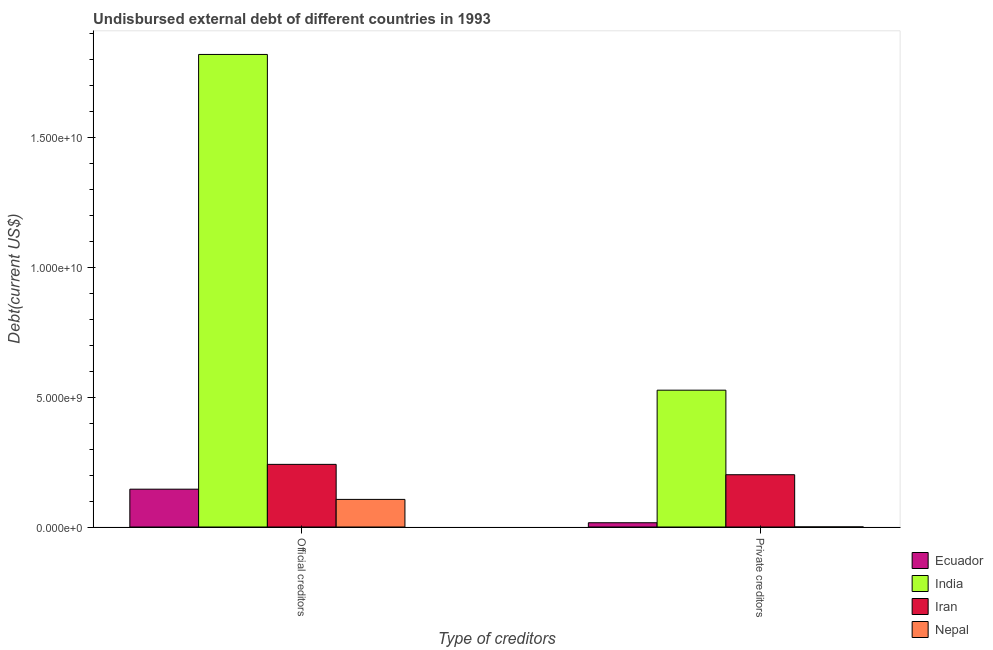How many different coloured bars are there?
Provide a succinct answer. 4. How many groups of bars are there?
Offer a very short reply. 2. Are the number of bars per tick equal to the number of legend labels?
Provide a short and direct response. Yes. Are the number of bars on each tick of the X-axis equal?
Your answer should be very brief. Yes. What is the label of the 1st group of bars from the left?
Make the answer very short. Official creditors. What is the undisbursed external debt of official creditors in Iran?
Provide a succinct answer. 2.41e+09. Across all countries, what is the maximum undisbursed external debt of official creditors?
Give a very brief answer. 1.82e+1. Across all countries, what is the minimum undisbursed external debt of official creditors?
Make the answer very short. 1.06e+09. In which country was the undisbursed external debt of private creditors maximum?
Your answer should be very brief. India. In which country was the undisbursed external debt of private creditors minimum?
Ensure brevity in your answer.  Nepal. What is the total undisbursed external debt of private creditors in the graph?
Your answer should be compact. 7.45e+09. What is the difference between the undisbursed external debt of private creditors in Nepal and that in Iran?
Keep it short and to the point. -2.01e+09. What is the difference between the undisbursed external debt of official creditors in Ecuador and the undisbursed external debt of private creditors in Iran?
Your answer should be compact. -5.56e+08. What is the average undisbursed external debt of official creditors per country?
Your answer should be compact. 5.78e+09. What is the difference between the undisbursed external debt of private creditors and undisbursed external debt of official creditors in India?
Offer a very short reply. -1.29e+1. In how many countries, is the undisbursed external debt of private creditors greater than 16000000000 US$?
Offer a very short reply. 0. What is the ratio of the undisbursed external debt of official creditors in Iran to that in Ecuador?
Provide a short and direct response. 1.66. What does the 4th bar from the left in Official creditors represents?
Offer a terse response. Nepal. What does the 1st bar from the right in Private creditors represents?
Ensure brevity in your answer.  Nepal. How many bars are there?
Give a very brief answer. 8. Are all the bars in the graph horizontal?
Ensure brevity in your answer.  No. Are the values on the major ticks of Y-axis written in scientific E-notation?
Provide a succinct answer. Yes. How many legend labels are there?
Provide a short and direct response. 4. How are the legend labels stacked?
Make the answer very short. Vertical. What is the title of the graph?
Your answer should be very brief. Undisbursed external debt of different countries in 1993. Does "Channel Islands" appear as one of the legend labels in the graph?
Offer a very short reply. No. What is the label or title of the X-axis?
Offer a very short reply. Type of creditors. What is the label or title of the Y-axis?
Your response must be concise. Debt(current US$). What is the Debt(current US$) in Ecuador in Official creditors?
Make the answer very short. 1.46e+09. What is the Debt(current US$) in India in Official creditors?
Ensure brevity in your answer.  1.82e+1. What is the Debt(current US$) in Iran in Official creditors?
Ensure brevity in your answer.  2.41e+09. What is the Debt(current US$) of Nepal in Official creditors?
Provide a succinct answer. 1.06e+09. What is the Debt(current US$) of Ecuador in Private creditors?
Offer a very short reply. 1.64e+08. What is the Debt(current US$) of India in Private creditors?
Give a very brief answer. 5.27e+09. What is the Debt(current US$) in Iran in Private creditors?
Your response must be concise. 2.01e+09. What is the Debt(current US$) of Nepal in Private creditors?
Ensure brevity in your answer.  2.78e+06. Across all Type of creditors, what is the maximum Debt(current US$) in Ecuador?
Provide a short and direct response. 1.46e+09. Across all Type of creditors, what is the maximum Debt(current US$) of India?
Provide a succinct answer. 1.82e+1. Across all Type of creditors, what is the maximum Debt(current US$) in Iran?
Ensure brevity in your answer.  2.41e+09. Across all Type of creditors, what is the maximum Debt(current US$) in Nepal?
Your answer should be compact. 1.06e+09. Across all Type of creditors, what is the minimum Debt(current US$) of Ecuador?
Offer a very short reply. 1.64e+08. Across all Type of creditors, what is the minimum Debt(current US$) in India?
Offer a terse response. 5.27e+09. Across all Type of creditors, what is the minimum Debt(current US$) of Iran?
Offer a very short reply. 2.01e+09. Across all Type of creditors, what is the minimum Debt(current US$) of Nepal?
Keep it short and to the point. 2.78e+06. What is the total Debt(current US$) of Ecuador in the graph?
Keep it short and to the point. 1.62e+09. What is the total Debt(current US$) in India in the graph?
Your answer should be compact. 2.35e+1. What is the total Debt(current US$) in Iran in the graph?
Your answer should be compact. 4.42e+09. What is the total Debt(current US$) of Nepal in the graph?
Keep it short and to the point. 1.07e+09. What is the difference between the Debt(current US$) of Ecuador in Official creditors and that in Private creditors?
Give a very brief answer. 1.29e+09. What is the difference between the Debt(current US$) in India in Official creditors and that in Private creditors?
Ensure brevity in your answer.  1.29e+1. What is the difference between the Debt(current US$) of Iran in Official creditors and that in Private creditors?
Keep it short and to the point. 3.99e+08. What is the difference between the Debt(current US$) in Nepal in Official creditors and that in Private creditors?
Offer a very short reply. 1.06e+09. What is the difference between the Debt(current US$) in Ecuador in Official creditors and the Debt(current US$) in India in Private creditors?
Offer a very short reply. -3.81e+09. What is the difference between the Debt(current US$) of Ecuador in Official creditors and the Debt(current US$) of Iran in Private creditors?
Keep it short and to the point. -5.56e+08. What is the difference between the Debt(current US$) in Ecuador in Official creditors and the Debt(current US$) in Nepal in Private creditors?
Give a very brief answer. 1.45e+09. What is the difference between the Debt(current US$) in India in Official creditors and the Debt(current US$) in Iran in Private creditors?
Your answer should be compact. 1.62e+1. What is the difference between the Debt(current US$) of India in Official creditors and the Debt(current US$) of Nepal in Private creditors?
Offer a terse response. 1.82e+1. What is the difference between the Debt(current US$) in Iran in Official creditors and the Debt(current US$) in Nepal in Private creditors?
Your answer should be compact. 2.41e+09. What is the average Debt(current US$) in Ecuador per Type of creditors?
Provide a short and direct response. 8.10e+08. What is the average Debt(current US$) in India per Type of creditors?
Offer a very short reply. 1.17e+1. What is the average Debt(current US$) in Iran per Type of creditors?
Your answer should be compact. 2.21e+09. What is the average Debt(current US$) of Nepal per Type of creditors?
Your answer should be compact. 5.33e+08. What is the difference between the Debt(current US$) of Ecuador and Debt(current US$) of India in Official creditors?
Give a very brief answer. -1.67e+1. What is the difference between the Debt(current US$) of Ecuador and Debt(current US$) of Iran in Official creditors?
Offer a very short reply. -9.55e+08. What is the difference between the Debt(current US$) in Ecuador and Debt(current US$) in Nepal in Official creditors?
Provide a short and direct response. 3.93e+08. What is the difference between the Debt(current US$) of India and Debt(current US$) of Iran in Official creditors?
Your answer should be very brief. 1.58e+1. What is the difference between the Debt(current US$) of India and Debt(current US$) of Nepal in Official creditors?
Provide a succinct answer. 1.71e+1. What is the difference between the Debt(current US$) in Iran and Debt(current US$) in Nepal in Official creditors?
Offer a terse response. 1.35e+09. What is the difference between the Debt(current US$) in Ecuador and Debt(current US$) in India in Private creditors?
Your answer should be compact. -5.10e+09. What is the difference between the Debt(current US$) in Ecuador and Debt(current US$) in Iran in Private creditors?
Offer a terse response. -1.85e+09. What is the difference between the Debt(current US$) of Ecuador and Debt(current US$) of Nepal in Private creditors?
Offer a very short reply. 1.61e+08. What is the difference between the Debt(current US$) in India and Debt(current US$) in Iran in Private creditors?
Make the answer very short. 3.25e+09. What is the difference between the Debt(current US$) of India and Debt(current US$) of Nepal in Private creditors?
Provide a short and direct response. 5.26e+09. What is the difference between the Debt(current US$) of Iran and Debt(current US$) of Nepal in Private creditors?
Offer a very short reply. 2.01e+09. What is the ratio of the Debt(current US$) of Ecuador in Official creditors to that in Private creditors?
Make the answer very short. 8.87. What is the ratio of the Debt(current US$) in India in Official creditors to that in Private creditors?
Your answer should be compact. 3.45. What is the ratio of the Debt(current US$) in Iran in Official creditors to that in Private creditors?
Provide a short and direct response. 1.2. What is the ratio of the Debt(current US$) of Nepal in Official creditors to that in Private creditors?
Offer a very short reply. 382.23. What is the difference between the highest and the second highest Debt(current US$) in Ecuador?
Provide a short and direct response. 1.29e+09. What is the difference between the highest and the second highest Debt(current US$) in India?
Provide a short and direct response. 1.29e+1. What is the difference between the highest and the second highest Debt(current US$) of Iran?
Make the answer very short. 3.99e+08. What is the difference between the highest and the second highest Debt(current US$) of Nepal?
Give a very brief answer. 1.06e+09. What is the difference between the highest and the lowest Debt(current US$) in Ecuador?
Your answer should be very brief. 1.29e+09. What is the difference between the highest and the lowest Debt(current US$) in India?
Provide a succinct answer. 1.29e+1. What is the difference between the highest and the lowest Debt(current US$) in Iran?
Make the answer very short. 3.99e+08. What is the difference between the highest and the lowest Debt(current US$) in Nepal?
Keep it short and to the point. 1.06e+09. 